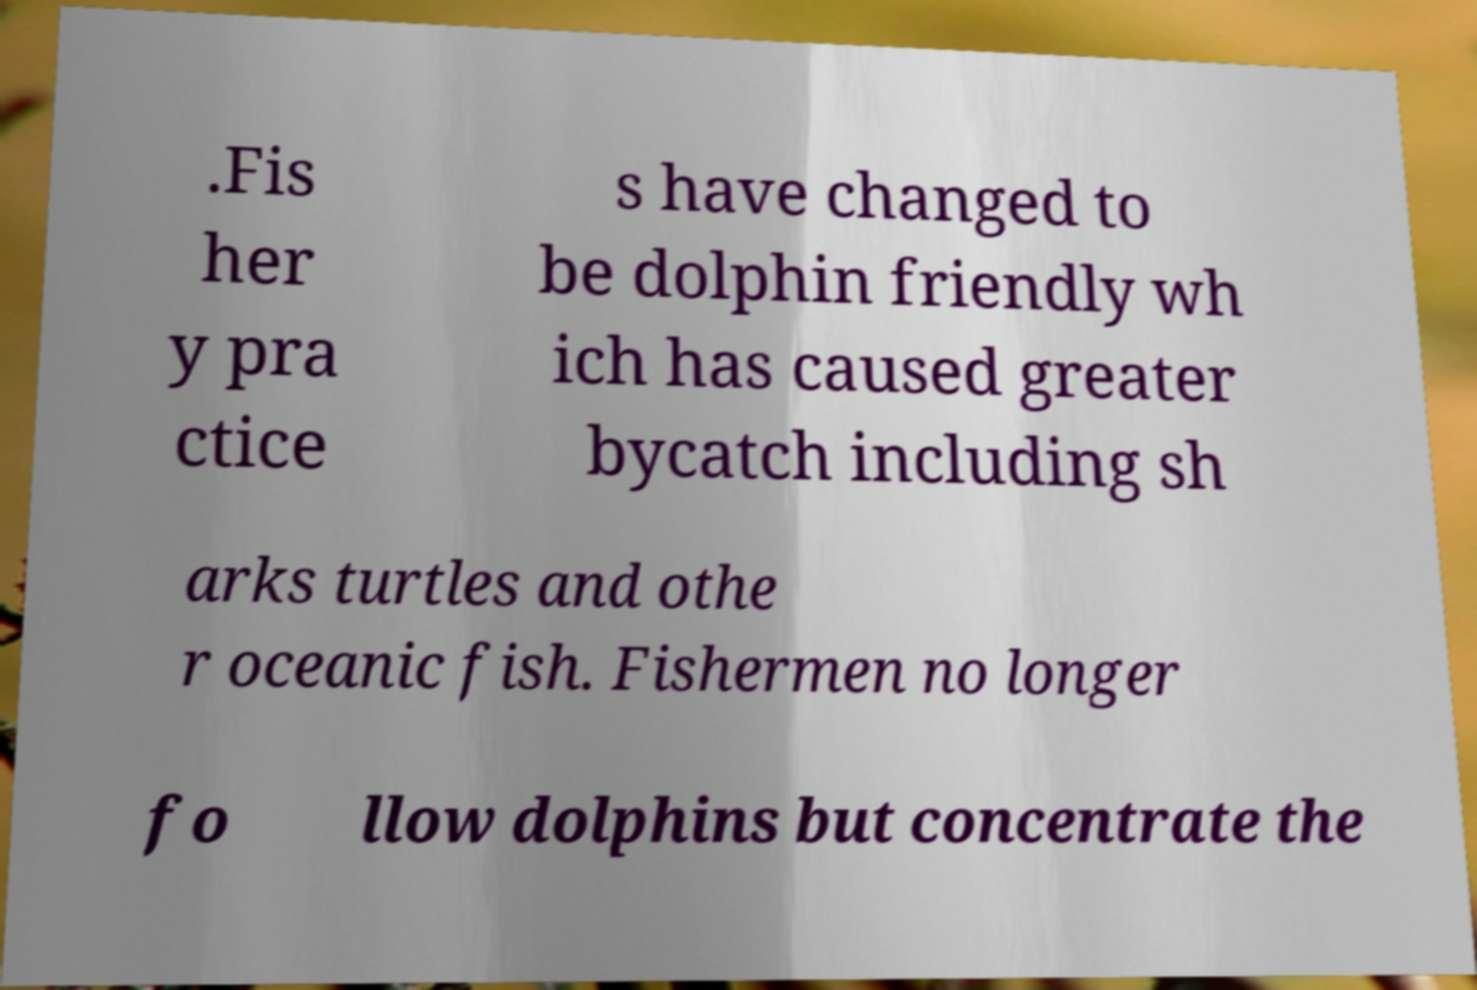For documentation purposes, I need the text within this image transcribed. Could you provide that? .Fis her y pra ctice s have changed to be dolphin friendly wh ich has caused greater bycatch including sh arks turtles and othe r oceanic fish. Fishermen no longer fo llow dolphins but concentrate the 